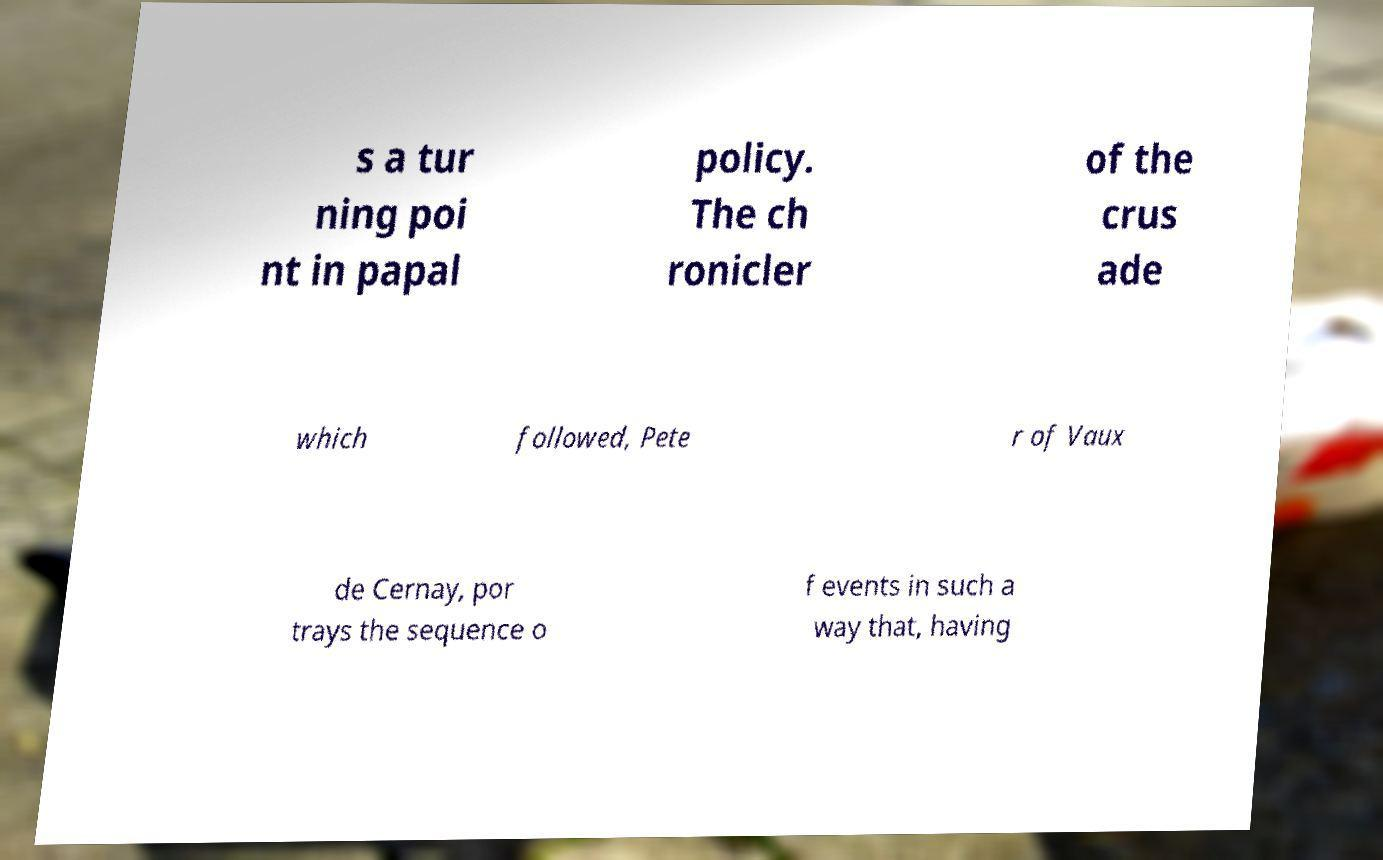Can you accurately transcribe the text from the provided image for me? s a tur ning poi nt in papal policy. The ch ronicler of the crus ade which followed, Pete r of Vaux de Cernay, por trays the sequence o f events in such a way that, having 